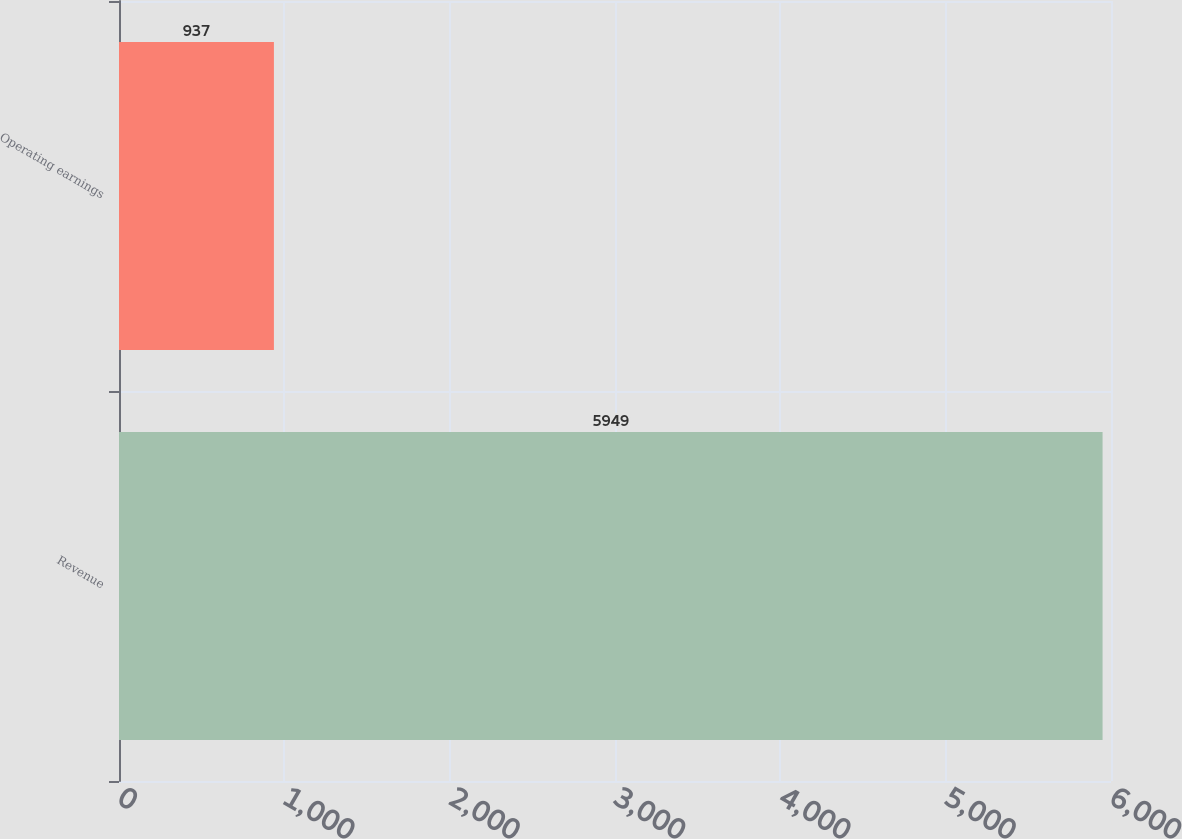Convert chart. <chart><loc_0><loc_0><loc_500><loc_500><bar_chart><fcel>Revenue<fcel>Operating earnings<nl><fcel>5949<fcel>937<nl></chart> 